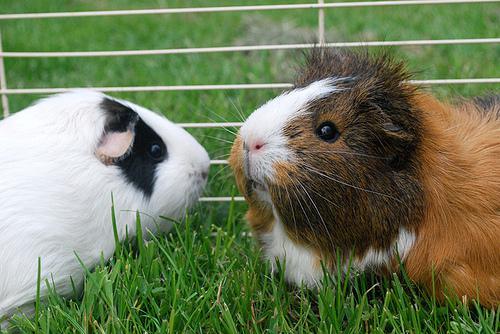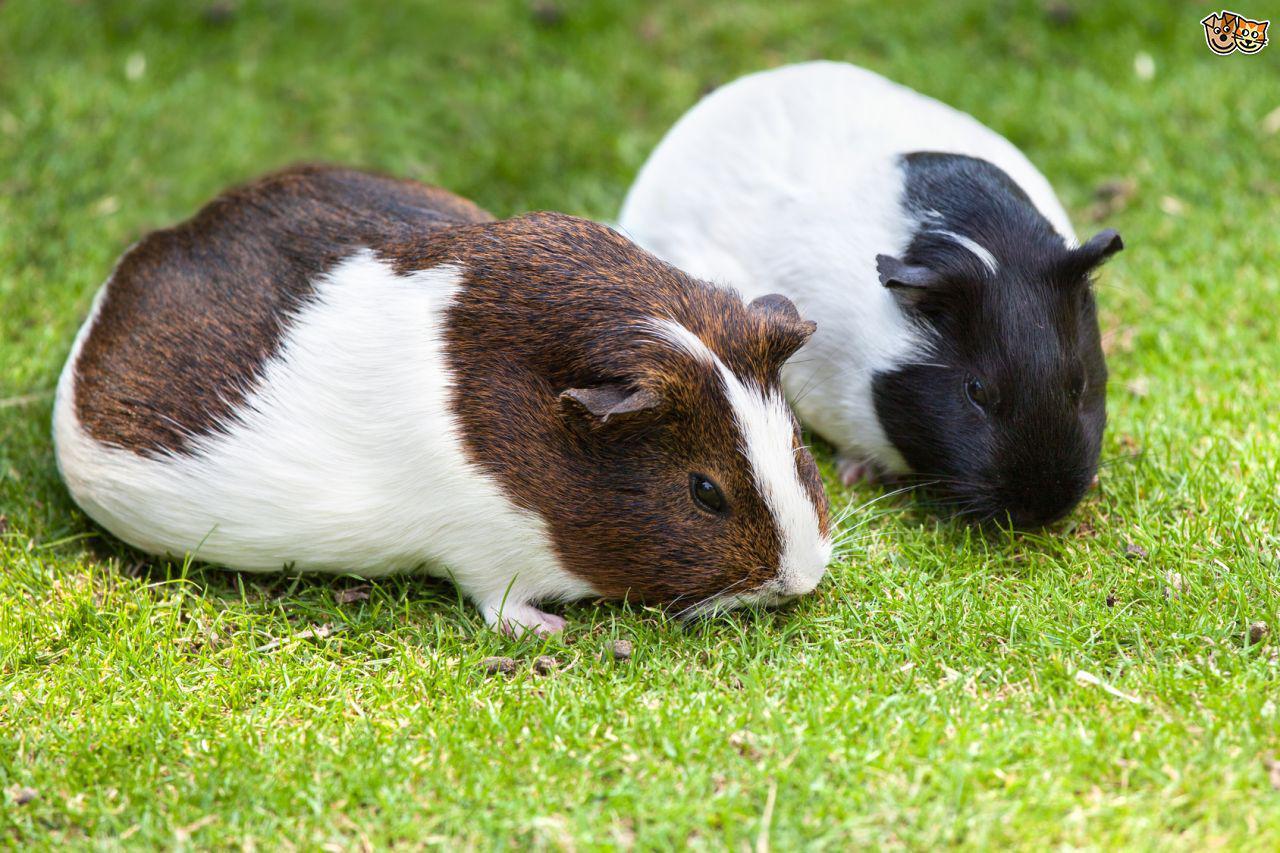The first image is the image on the left, the second image is the image on the right. For the images shown, is this caption "There are 5 hamsters in the grass." true? Answer yes or no. No. 